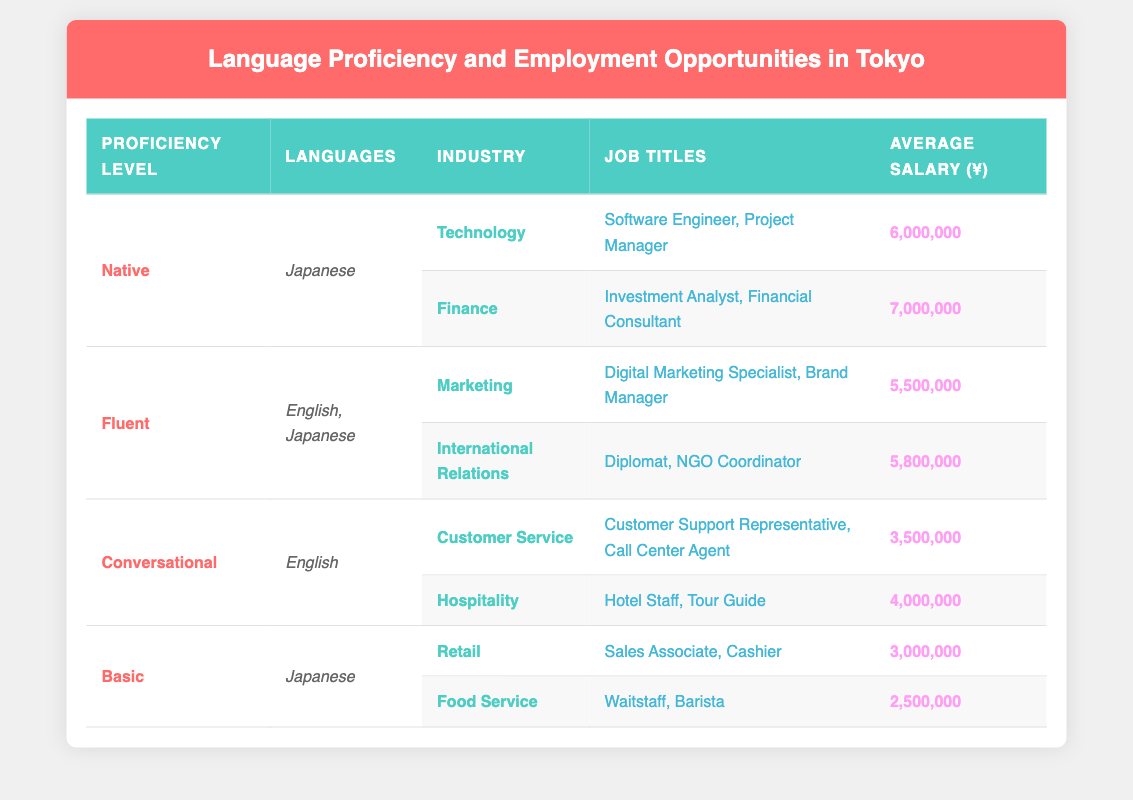What industries offer employment opportunities for those with Native proficiency in Japanese? According to the table, individuals with Native proficiency in Japanese can find opportunities in the Technology and Finance industries.
Answer: Technology, Finance What is the highest average salary listed for any job title in the table? The table shows that the highest average salary is for job titles in the Finance industry, which is 7,000,000 yen.
Answer: 7,000,000 Can a person with Basic Japanese proficiency work in the Hospitality industry? Yes, according to the table, Basic Japanese proficiency allows a person to work in the Hospitality industry as a Tour Guide or Hotel Staff.
Answer: Yes What are the average salaries for jobs in the International Relations industry for those who are Fluent? The average salary for jobs in the International Relations industry for Fluent individuals is 5,800,000 yen as depicted in the table.
Answer: 5,800,000 How many job titles are listed under the Conversational proficiency level? There are four job titles listed under the Conversational proficiency level: Customer Support Representative, Call Center Agent, Hotel Staff, and Tour Guide.
Answer: 4 What is the difference between the average salaries of Retail and Food Service jobs for those with Basic proficiency? The average salary for Retail jobs is 3,000,000 yen, and for Food Service jobs, it is 2,500,000 yen. The difference is calculated as 3,000,000 - 2,500,000 = 500,000 yen.
Answer: 500,000 Are there any job titles under the Fluent proficiency level that earn less than those under Native proficiency? Yes, all job titles under the Fluent proficiency level (with average salaries of 5,500,000 and 5,800,000 yen) earn less than the highest salary under Native proficiency (7,000,000 yen).
Answer: Yes What is the total number of different industries represented for all proficiency levels? The table lists the following industries: Technology, Finance, Marketing, International Relations, Customer Service, Hospitality, Retail, and Food Service. This amounts to a total of 8 different industries represented in the table.
Answer: 8 What job titles in the Technology industry have the same average salary in the table? In the Technology industry, both job titles (Software Engineer and Project Manager) have the same average salary of 6,000,000 yen, according to the table.
Answer: Software Engineer, Project Manager 